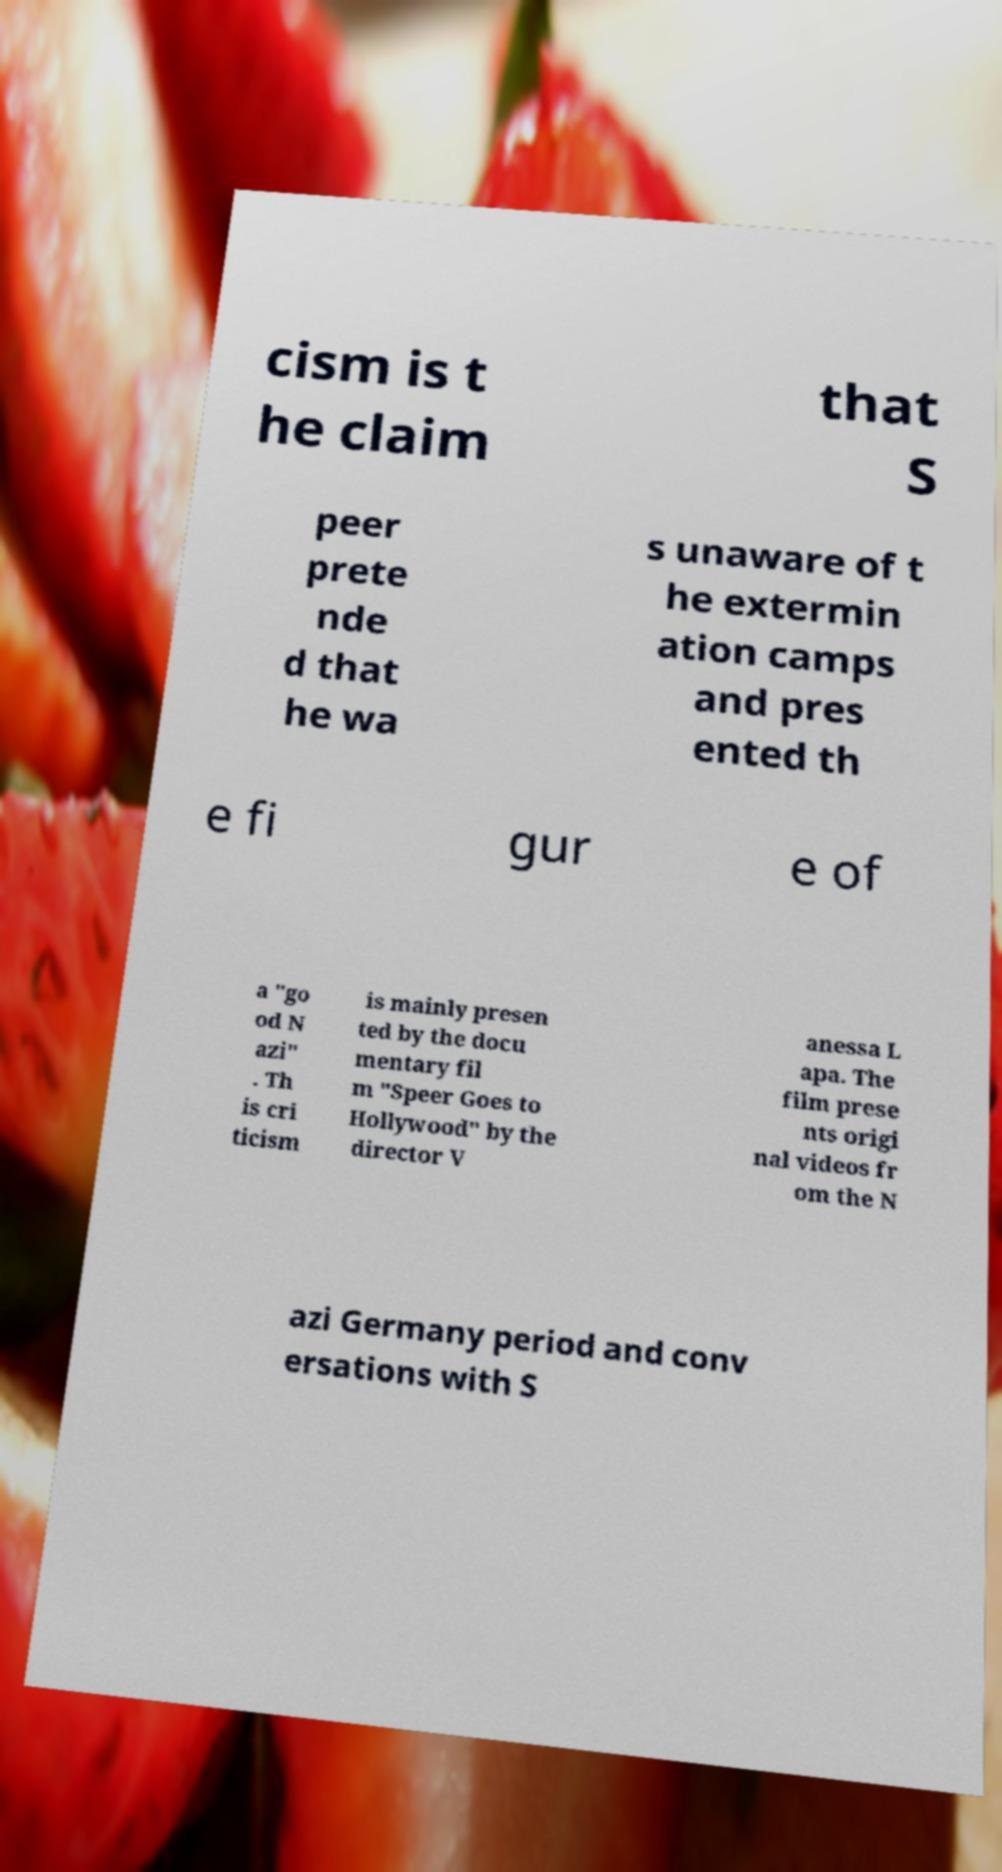I need the written content from this picture converted into text. Can you do that? cism is t he claim that S peer prete nde d that he wa s unaware of t he extermin ation camps and pres ented th e fi gur e of a "go od N azi" . Th is cri ticism is mainly presen ted by the docu mentary fil m "Speer Goes to Hollywood" by the director V anessa L apa. The film prese nts origi nal videos fr om the N azi Germany period and conv ersations with S 